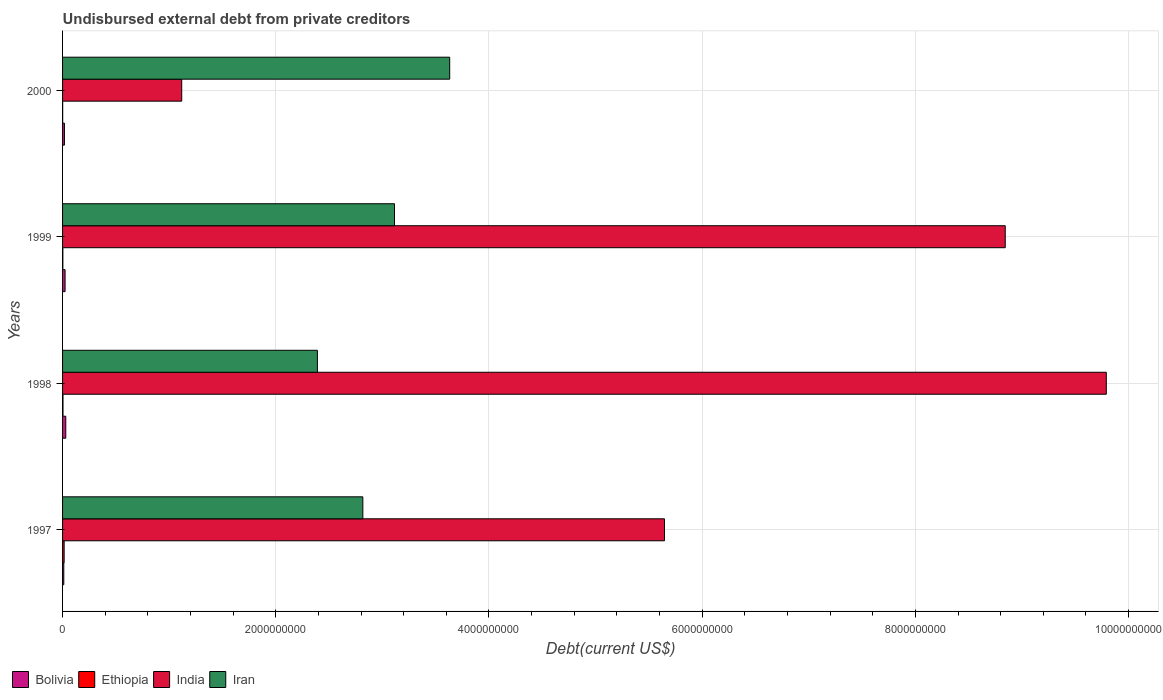How many different coloured bars are there?
Keep it short and to the point. 4. How many groups of bars are there?
Offer a very short reply. 4. Are the number of bars per tick equal to the number of legend labels?
Your answer should be compact. Yes. Are the number of bars on each tick of the Y-axis equal?
Your answer should be very brief. Yes. How many bars are there on the 1st tick from the top?
Your answer should be compact. 4. How many bars are there on the 1st tick from the bottom?
Your answer should be compact. 4. What is the label of the 3rd group of bars from the top?
Offer a very short reply. 1998. In how many cases, is the number of bars for a given year not equal to the number of legend labels?
Offer a very short reply. 0. What is the total debt in Bolivia in 1997?
Provide a short and direct response. 1.15e+07. Across all years, what is the maximum total debt in Iran?
Make the answer very short. 3.63e+09. Across all years, what is the minimum total debt in Ethiopia?
Offer a very short reply. 9.53e+05. In which year was the total debt in Ethiopia minimum?
Your answer should be compact. 2000. What is the total total debt in Ethiopia in the graph?
Your response must be concise. 2.25e+07. What is the difference between the total debt in India in 1998 and that in 2000?
Your answer should be compact. 8.67e+09. What is the difference between the total debt in Iran in 1998 and the total debt in Ethiopia in 1997?
Your response must be concise. 2.38e+09. What is the average total debt in Bolivia per year?
Keep it short and to the point. 2.07e+07. In the year 1997, what is the difference between the total debt in India and total debt in Iran?
Ensure brevity in your answer.  2.83e+09. What is the ratio of the total debt in Bolivia in 1998 to that in 1999?
Your answer should be compact. 1.28. Is the difference between the total debt in India in 1997 and 1999 greater than the difference between the total debt in Iran in 1997 and 1999?
Offer a very short reply. No. What is the difference between the highest and the second highest total debt in Iran?
Keep it short and to the point. 5.18e+08. What is the difference between the highest and the lowest total debt in Iran?
Ensure brevity in your answer.  1.24e+09. Is the sum of the total debt in Ethiopia in 1998 and 1999 greater than the maximum total debt in Iran across all years?
Your answer should be compact. No. Is it the case that in every year, the sum of the total debt in Bolivia and total debt in Ethiopia is greater than the sum of total debt in Iran and total debt in India?
Make the answer very short. No. What does the 2nd bar from the bottom in 2000 represents?
Keep it short and to the point. Ethiopia. Is it the case that in every year, the sum of the total debt in Iran and total debt in Ethiopia is greater than the total debt in India?
Your answer should be very brief. No. Are all the bars in the graph horizontal?
Your answer should be very brief. Yes. How many years are there in the graph?
Make the answer very short. 4. How many legend labels are there?
Provide a succinct answer. 4. How are the legend labels stacked?
Keep it short and to the point. Horizontal. What is the title of the graph?
Ensure brevity in your answer.  Undisbursed external debt from private creditors. Does "Grenada" appear as one of the legend labels in the graph?
Your response must be concise. No. What is the label or title of the X-axis?
Make the answer very short. Debt(current US$). What is the label or title of the Y-axis?
Offer a terse response. Years. What is the Debt(current US$) in Bolivia in 1997?
Your response must be concise. 1.15e+07. What is the Debt(current US$) in Ethiopia in 1997?
Ensure brevity in your answer.  1.47e+07. What is the Debt(current US$) of India in 1997?
Ensure brevity in your answer.  5.65e+09. What is the Debt(current US$) of Iran in 1997?
Provide a short and direct response. 2.82e+09. What is the Debt(current US$) of Bolivia in 1998?
Ensure brevity in your answer.  3.00e+07. What is the Debt(current US$) in Ethiopia in 1998?
Give a very brief answer. 4.14e+06. What is the Debt(current US$) of India in 1998?
Your response must be concise. 9.79e+09. What is the Debt(current US$) in Iran in 1998?
Your answer should be very brief. 2.39e+09. What is the Debt(current US$) in Bolivia in 1999?
Make the answer very short. 2.35e+07. What is the Debt(current US$) in Ethiopia in 1999?
Provide a short and direct response. 2.69e+06. What is the Debt(current US$) in India in 1999?
Your answer should be very brief. 8.84e+09. What is the Debt(current US$) in Iran in 1999?
Provide a succinct answer. 3.11e+09. What is the Debt(current US$) of Bolivia in 2000?
Your answer should be compact. 1.76e+07. What is the Debt(current US$) in Ethiopia in 2000?
Make the answer very short. 9.53e+05. What is the Debt(current US$) of India in 2000?
Your response must be concise. 1.12e+09. What is the Debt(current US$) of Iran in 2000?
Ensure brevity in your answer.  3.63e+09. Across all years, what is the maximum Debt(current US$) in Bolivia?
Your answer should be very brief. 3.00e+07. Across all years, what is the maximum Debt(current US$) of Ethiopia?
Make the answer very short. 1.47e+07. Across all years, what is the maximum Debt(current US$) in India?
Make the answer very short. 9.79e+09. Across all years, what is the maximum Debt(current US$) in Iran?
Offer a terse response. 3.63e+09. Across all years, what is the minimum Debt(current US$) of Bolivia?
Your response must be concise. 1.15e+07. Across all years, what is the minimum Debt(current US$) of Ethiopia?
Ensure brevity in your answer.  9.53e+05. Across all years, what is the minimum Debt(current US$) in India?
Ensure brevity in your answer.  1.12e+09. Across all years, what is the minimum Debt(current US$) in Iran?
Your response must be concise. 2.39e+09. What is the total Debt(current US$) of Bolivia in the graph?
Your answer should be very brief. 8.26e+07. What is the total Debt(current US$) of Ethiopia in the graph?
Your response must be concise. 2.25e+07. What is the total Debt(current US$) in India in the graph?
Make the answer very short. 2.54e+1. What is the total Debt(current US$) of Iran in the graph?
Make the answer very short. 1.20e+1. What is the difference between the Debt(current US$) in Bolivia in 1997 and that in 1998?
Keep it short and to the point. -1.85e+07. What is the difference between the Debt(current US$) of Ethiopia in 1997 and that in 1998?
Make the answer very short. 1.06e+07. What is the difference between the Debt(current US$) of India in 1997 and that in 1998?
Offer a terse response. -4.14e+09. What is the difference between the Debt(current US$) of Iran in 1997 and that in 1998?
Ensure brevity in your answer.  4.26e+08. What is the difference between the Debt(current US$) of Bolivia in 1997 and that in 1999?
Make the answer very short. -1.20e+07. What is the difference between the Debt(current US$) of Ethiopia in 1997 and that in 1999?
Give a very brief answer. 1.21e+07. What is the difference between the Debt(current US$) of India in 1997 and that in 1999?
Your response must be concise. -3.20e+09. What is the difference between the Debt(current US$) of Iran in 1997 and that in 1999?
Make the answer very short. -2.97e+08. What is the difference between the Debt(current US$) in Bolivia in 1997 and that in 2000?
Offer a very short reply. -6.14e+06. What is the difference between the Debt(current US$) of Ethiopia in 1997 and that in 2000?
Provide a succinct answer. 1.38e+07. What is the difference between the Debt(current US$) in India in 1997 and that in 2000?
Ensure brevity in your answer.  4.53e+09. What is the difference between the Debt(current US$) in Iran in 1997 and that in 2000?
Provide a succinct answer. -8.15e+08. What is the difference between the Debt(current US$) of Bolivia in 1998 and that in 1999?
Your response must be concise. 6.48e+06. What is the difference between the Debt(current US$) in Ethiopia in 1998 and that in 1999?
Your answer should be compact. 1.46e+06. What is the difference between the Debt(current US$) in India in 1998 and that in 1999?
Make the answer very short. 9.48e+08. What is the difference between the Debt(current US$) in Iran in 1998 and that in 1999?
Provide a succinct answer. -7.23e+08. What is the difference between the Debt(current US$) of Bolivia in 1998 and that in 2000?
Give a very brief answer. 1.24e+07. What is the difference between the Debt(current US$) of Ethiopia in 1998 and that in 2000?
Your answer should be compact. 3.19e+06. What is the difference between the Debt(current US$) in India in 1998 and that in 2000?
Your answer should be compact. 8.67e+09. What is the difference between the Debt(current US$) in Iran in 1998 and that in 2000?
Offer a very short reply. -1.24e+09. What is the difference between the Debt(current US$) in Bolivia in 1999 and that in 2000?
Give a very brief answer. 5.89e+06. What is the difference between the Debt(current US$) in Ethiopia in 1999 and that in 2000?
Make the answer very short. 1.74e+06. What is the difference between the Debt(current US$) in India in 1999 and that in 2000?
Your answer should be very brief. 7.73e+09. What is the difference between the Debt(current US$) in Iran in 1999 and that in 2000?
Your response must be concise. -5.18e+08. What is the difference between the Debt(current US$) of Bolivia in 1997 and the Debt(current US$) of Ethiopia in 1998?
Make the answer very short. 7.34e+06. What is the difference between the Debt(current US$) of Bolivia in 1997 and the Debt(current US$) of India in 1998?
Provide a short and direct response. -9.78e+09. What is the difference between the Debt(current US$) of Bolivia in 1997 and the Debt(current US$) of Iran in 1998?
Offer a very short reply. -2.38e+09. What is the difference between the Debt(current US$) in Ethiopia in 1997 and the Debt(current US$) in India in 1998?
Your response must be concise. -9.78e+09. What is the difference between the Debt(current US$) of Ethiopia in 1997 and the Debt(current US$) of Iran in 1998?
Your answer should be very brief. -2.38e+09. What is the difference between the Debt(current US$) of India in 1997 and the Debt(current US$) of Iran in 1998?
Ensure brevity in your answer.  3.26e+09. What is the difference between the Debt(current US$) of Bolivia in 1997 and the Debt(current US$) of Ethiopia in 1999?
Your answer should be very brief. 8.80e+06. What is the difference between the Debt(current US$) of Bolivia in 1997 and the Debt(current US$) of India in 1999?
Your response must be concise. -8.83e+09. What is the difference between the Debt(current US$) of Bolivia in 1997 and the Debt(current US$) of Iran in 1999?
Provide a succinct answer. -3.10e+09. What is the difference between the Debt(current US$) of Ethiopia in 1997 and the Debt(current US$) of India in 1999?
Provide a succinct answer. -8.83e+09. What is the difference between the Debt(current US$) of Ethiopia in 1997 and the Debt(current US$) of Iran in 1999?
Give a very brief answer. -3.10e+09. What is the difference between the Debt(current US$) of India in 1997 and the Debt(current US$) of Iran in 1999?
Make the answer very short. 2.53e+09. What is the difference between the Debt(current US$) of Bolivia in 1997 and the Debt(current US$) of Ethiopia in 2000?
Your answer should be very brief. 1.05e+07. What is the difference between the Debt(current US$) of Bolivia in 1997 and the Debt(current US$) of India in 2000?
Ensure brevity in your answer.  -1.11e+09. What is the difference between the Debt(current US$) in Bolivia in 1997 and the Debt(current US$) in Iran in 2000?
Offer a very short reply. -3.62e+09. What is the difference between the Debt(current US$) of Ethiopia in 1997 and the Debt(current US$) of India in 2000?
Give a very brief answer. -1.10e+09. What is the difference between the Debt(current US$) in Ethiopia in 1997 and the Debt(current US$) in Iran in 2000?
Your answer should be compact. -3.62e+09. What is the difference between the Debt(current US$) of India in 1997 and the Debt(current US$) of Iran in 2000?
Provide a short and direct response. 2.01e+09. What is the difference between the Debt(current US$) in Bolivia in 1998 and the Debt(current US$) in Ethiopia in 1999?
Your answer should be compact. 2.73e+07. What is the difference between the Debt(current US$) in Bolivia in 1998 and the Debt(current US$) in India in 1999?
Give a very brief answer. -8.81e+09. What is the difference between the Debt(current US$) of Bolivia in 1998 and the Debt(current US$) of Iran in 1999?
Keep it short and to the point. -3.08e+09. What is the difference between the Debt(current US$) in Ethiopia in 1998 and the Debt(current US$) in India in 1999?
Make the answer very short. -8.84e+09. What is the difference between the Debt(current US$) in Ethiopia in 1998 and the Debt(current US$) in Iran in 1999?
Your answer should be compact. -3.11e+09. What is the difference between the Debt(current US$) in India in 1998 and the Debt(current US$) in Iran in 1999?
Offer a terse response. 6.68e+09. What is the difference between the Debt(current US$) in Bolivia in 1998 and the Debt(current US$) in Ethiopia in 2000?
Your answer should be very brief. 2.90e+07. What is the difference between the Debt(current US$) in Bolivia in 1998 and the Debt(current US$) in India in 2000?
Provide a short and direct response. -1.09e+09. What is the difference between the Debt(current US$) in Bolivia in 1998 and the Debt(current US$) in Iran in 2000?
Your answer should be compact. -3.60e+09. What is the difference between the Debt(current US$) in Ethiopia in 1998 and the Debt(current US$) in India in 2000?
Your answer should be compact. -1.11e+09. What is the difference between the Debt(current US$) in Ethiopia in 1998 and the Debt(current US$) in Iran in 2000?
Your answer should be very brief. -3.63e+09. What is the difference between the Debt(current US$) in India in 1998 and the Debt(current US$) in Iran in 2000?
Ensure brevity in your answer.  6.16e+09. What is the difference between the Debt(current US$) in Bolivia in 1999 and the Debt(current US$) in Ethiopia in 2000?
Keep it short and to the point. 2.26e+07. What is the difference between the Debt(current US$) of Bolivia in 1999 and the Debt(current US$) of India in 2000?
Keep it short and to the point. -1.09e+09. What is the difference between the Debt(current US$) of Bolivia in 1999 and the Debt(current US$) of Iran in 2000?
Your response must be concise. -3.61e+09. What is the difference between the Debt(current US$) in Ethiopia in 1999 and the Debt(current US$) in India in 2000?
Your answer should be very brief. -1.12e+09. What is the difference between the Debt(current US$) in Ethiopia in 1999 and the Debt(current US$) in Iran in 2000?
Make the answer very short. -3.63e+09. What is the difference between the Debt(current US$) in India in 1999 and the Debt(current US$) in Iran in 2000?
Offer a terse response. 5.21e+09. What is the average Debt(current US$) of Bolivia per year?
Give a very brief answer. 2.07e+07. What is the average Debt(current US$) of Ethiopia per year?
Make the answer very short. 5.63e+06. What is the average Debt(current US$) in India per year?
Make the answer very short. 6.35e+09. What is the average Debt(current US$) of Iran per year?
Make the answer very short. 2.99e+09. In the year 1997, what is the difference between the Debt(current US$) of Bolivia and Debt(current US$) of Ethiopia?
Offer a terse response. -3.26e+06. In the year 1997, what is the difference between the Debt(current US$) of Bolivia and Debt(current US$) of India?
Give a very brief answer. -5.64e+09. In the year 1997, what is the difference between the Debt(current US$) in Bolivia and Debt(current US$) in Iran?
Offer a terse response. -2.81e+09. In the year 1997, what is the difference between the Debt(current US$) of Ethiopia and Debt(current US$) of India?
Your response must be concise. -5.63e+09. In the year 1997, what is the difference between the Debt(current US$) in Ethiopia and Debt(current US$) in Iran?
Ensure brevity in your answer.  -2.80e+09. In the year 1997, what is the difference between the Debt(current US$) of India and Debt(current US$) of Iran?
Provide a short and direct response. 2.83e+09. In the year 1998, what is the difference between the Debt(current US$) in Bolivia and Debt(current US$) in Ethiopia?
Provide a succinct answer. 2.59e+07. In the year 1998, what is the difference between the Debt(current US$) in Bolivia and Debt(current US$) in India?
Offer a very short reply. -9.76e+09. In the year 1998, what is the difference between the Debt(current US$) in Bolivia and Debt(current US$) in Iran?
Your response must be concise. -2.36e+09. In the year 1998, what is the difference between the Debt(current US$) in Ethiopia and Debt(current US$) in India?
Offer a very short reply. -9.79e+09. In the year 1998, what is the difference between the Debt(current US$) of Ethiopia and Debt(current US$) of Iran?
Your answer should be very brief. -2.39e+09. In the year 1998, what is the difference between the Debt(current US$) in India and Debt(current US$) in Iran?
Provide a succinct answer. 7.40e+09. In the year 1999, what is the difference between the Debt(current US$) of Bolivia and Debt(current US$) of Ethiopia?
Give a very brief answer. 2.08e+07. In the year 1999, what is the difference between the Debt(current US$) of Bolivia and Debt(current US$) of India?
Provide a succinct answer. -8.82e+09. In the year 1999, what is the difference between the Debt(current US$) in Bolivia and Debt(current US$) in Iran?
Give a very brief answer. -3.09e+09. In the year 1999, what is the difference between the Debt(current US$) in Ethiopia and Debt(current US$) in India?
Give a very brief answer. -8.84e+09. In the year 1999, what is the difference between the Debt(current US$) in Ethiopia and Debt(current US$) in Iran?
Your answer should be compact. -3.11e+09. In the year 1999, what is the difference between the Debt(current US$) in India and Debt(current US$) in Iran?
Keep it short and to the point. 5.73e+09. In the year 2000, what is the difference between the Debt(current US$) of Bolivia and Debt(current US$) of Ethiopia?
Keep it short and to the point. 1.67e+07. In the year 2000, what is the difference between the Debt(current US$) in Bolivia and Debt(current US$) in India?
Give a very brief answer. -1.10e+09. In the year 2000, what is the difference between the Debt(current US$) in Bolivia and Debt(current US$) in Iran?
Keep it short and to the point. -3.61e+09. In the year 2000, what is the difference between the Debt(current US$) in Ethiopia and Debt(current US$) in India?
Give a very brief answer. -1.12e+09. In the year 2000, what is the difference between the Debt(current US$) of Ethiopia and Debt(current US$) of Iran?
Your answer should be very brief. -3.63e+09. In the year 2000, what is the difference between the Debt(current US$) of India and Debt(current US$) of Iran?
Your answer should be very brief. -2.51e+09. What is the ratio of the Debt(current US$) in Bolivia in 1997 to that in 1998?
Provide a short and direct response. 0.38. What is the ratio of the Debt(current US$) of Ethiopia in 1997 to that in 1998?
Make the answer very short. 3.56. What is the ratio of the Debt(current US$) in India in 1997 to that in 1998?
Offer a terse response. 0.58. What is the ratio of the Debt(current US$) of Iran in 1997 to that in 1998?
Give a very brief answer. 1.18. What is the ratio of the Debt(current US$) of Bolivia in 1997 to that in 1999?
Ensure brevity in your answer.  0.49. What is the ratio of the Debt(current US$) in Ethiopia in 1997 to that in 1999?
Your response must be concise. 5.48. What is the ratio of the Debt(current US$) in India in 1997 to that in 1999?
Your answer should be very brief. 0.64. What is the ratio of the Debt(current US$) in Iran in 1997 to that in 1999?
Give a very brief answer. 0.9. What is the ratio of the Debt(current US$) of Bolivia in 1997 to that in 2000?
Ensure brevity in your answer.  0.65. What is the ratio of the Debt(current US$) of Ethiopia in 1997 to that in 2000?
Your answer should be compact. 15.48. What is the ratio of the Debt(current US$) of India in 1997 to that in 2000?
Your response must be concise. 5.05. What is the ratio of the Debt(current US$) in Iran in 1997 to that in 2000?
Your response must be concise. 0.78. What is the ratio of the Debt(current US$) of Bolivia in 1998 to that in 1999?
Offer a very short reply. 1.28. What is the ratio of the Debt(current US$) in Ethiopia in 1998 to that in 1999?
Give a very brief answer. 1.54. What is the ratio of the Debt(current US$) in India in 1998 to that in 1999?
Provide a short and direct response. 1.11. What is the ratio of the Debt(current US$) in Iran in 1998 to that in 1999?
Your response must be concise. 0.77. What is the ratio of the Debt(current US$) in Bolivia in 1998 to that in 2000?
Offer a very short reply. 1.7. What is the ratio of the Debt(current US$) in Ethiopia in 1998 to that in 2000?
Keep it short and to the point. 4.35. What is the ratio of the Debt(current US$) in India in 1998 to that in 2000?
Keep it short and to the point. 8.76. What is the ratio of the Debt(current US$) in Iran in 1998 to that in 2000?
Ensure brevity in your answer.  0.66. What is the ratio of the Debt(current US$) in Bolivia in 1999 to that in 2000?
Give a very brief answer. 1.33. What is the ratio of the Debt(current US$) of Ethiopia in 1999 to that in 2000?
Your response must be concise. 2.82. What is the ratio of the Debt(current US$) of India in 1999 to that in 2000?
Give a very brief answer. 7.91. What is the ratio of the Debt(current US$) in Iran in 1999 to that in 2000?
Ensure brevity in your answer.  0.86. What is the difference between the highest and the second highest Debt(current US$) in Bolivia?
Give a very brief answer. 6.48e+06. What is the difference between the highest and the second highest Debt(current US$) of Ethiopia?
Offer a terse response. 1.06e+07. What is the difference between the highest and the second highest Debt(current US$) of India?
Ensure brevity in your answer.  9.48e+08. What is the difference between the highest and the second highest Debt(current US$) of Iran?
Make the answer very short. 5.18e+08. What is the difference between the highest and the lowest Debt(current US$) in Bolivia?
Ensure brevity in your answer.  1.85e+07. What is the difference between the highest and the lowest Debt(current US$) of Ethiopia?
Your answer should be very brief. 1.38e+07. What is the difference between the highest and the lowest Debt(current US$) of India?
Provide a succinct answer. 8.67e+09. What is the difference between the highest and the lowest Debt(current US$) in Iran?
Offer a terse response. 1.24e+09. 